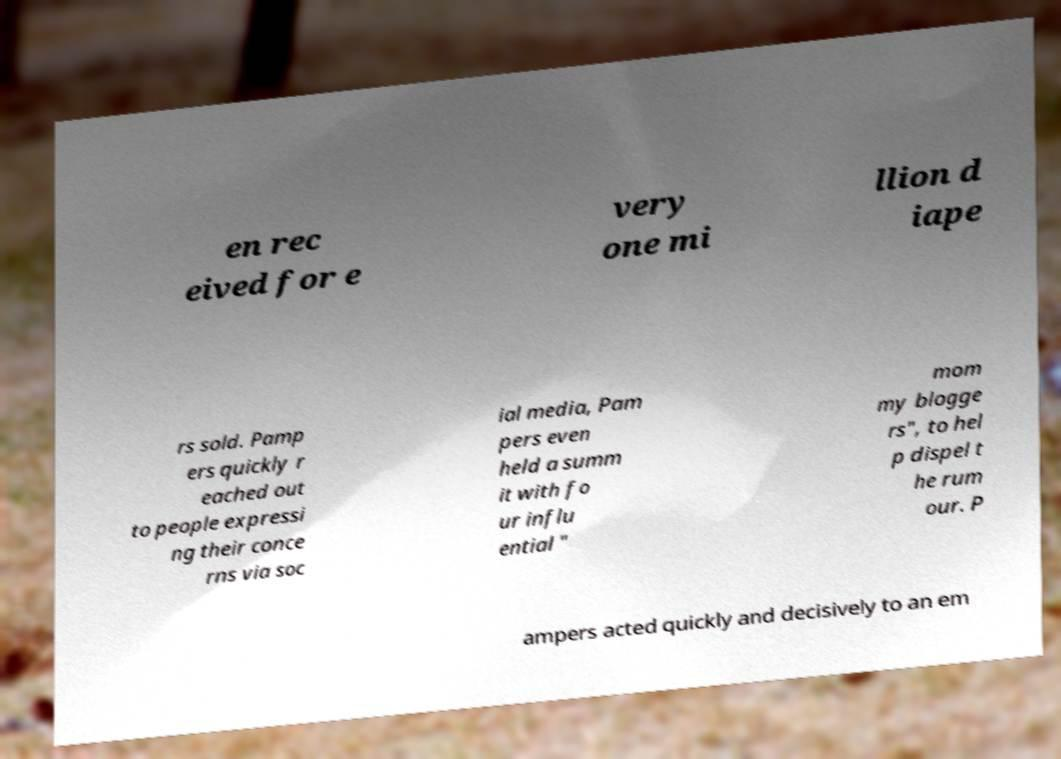Please read and relay the text visible in this image. What does it say? en rec eived for e very one mi llion d iape rs sold. Pamp ers quickly r eached out to people expressi ng their conce rns via soc ial media, Pam pers even held a summ it with fo ur influ ential " mom my blogge rs", to hel p dispel t he rum our. P ampers acted quickly and decisively to an em 